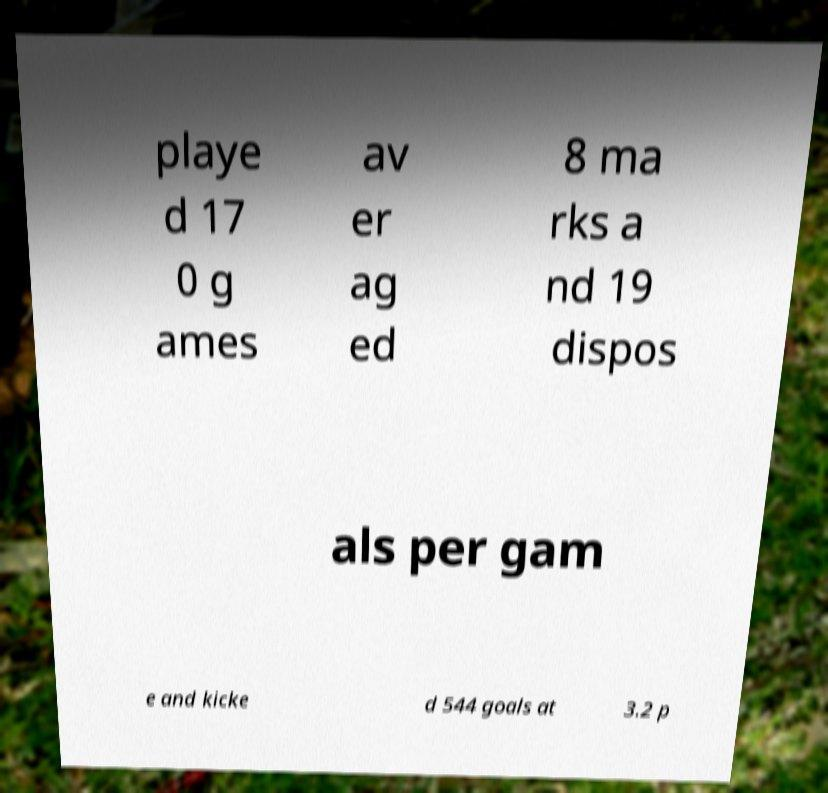Please read and relay the text visible in this image. What does it say? playe d 17 0 g ames av er ag ed 8 ma rks a nd 19 dispos als per gam e and kicke d 544 goals at 3.2 p 